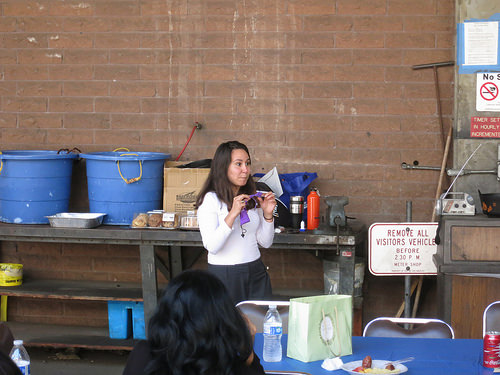<image>
Is the sign to the right of the table? No. The sign is not to the right of the table. The horizontal positioning shows a different relationship. 